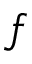Convert formula to latex. <formula><loc_0><loc_0><loc_500><loc_500>f</formula> 